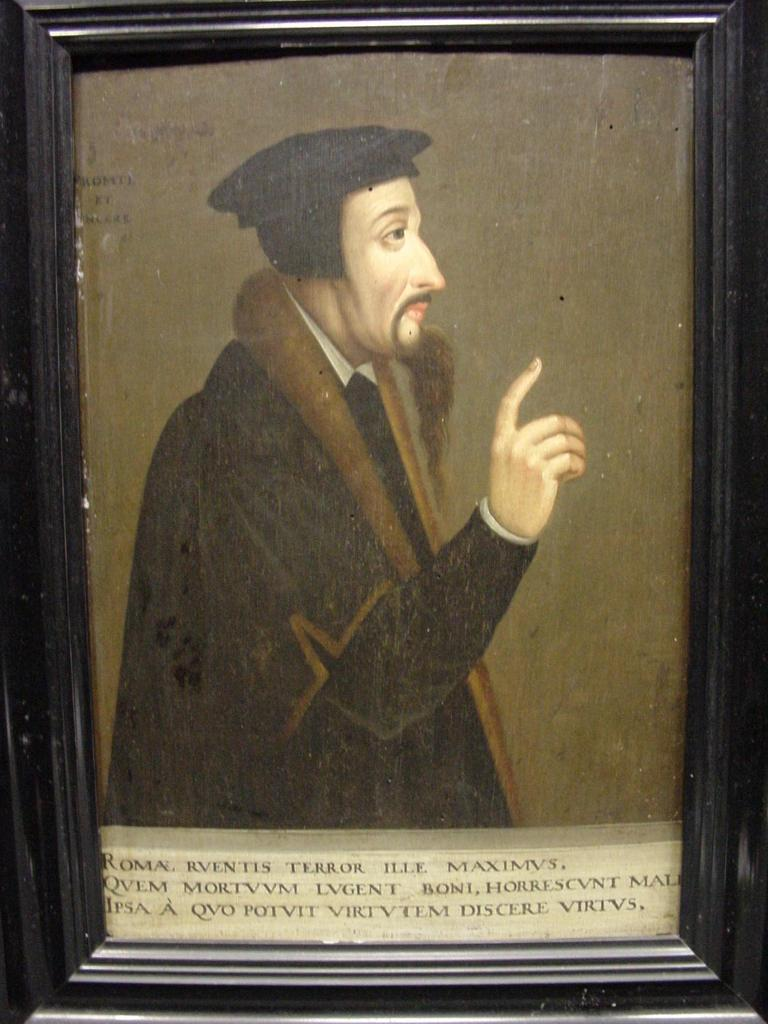What is the color of the photo frame in the image? The photo frame in the image is black colored. What is inside the photo frame? The photo frame contains a photograph of a person. What is the person in the photograph wearing? The person in the photograph is wearing a brown and black colored dress. Is there any text present in the image? Yes, there is text written at the bottom of the image. Can you see any recess in the image? There is no recess present in the image; it features a photo frame with a photograph and text. Is there a cave visible in the image? There is no cave present in the image; it features a photo frame with a photograph and text. 